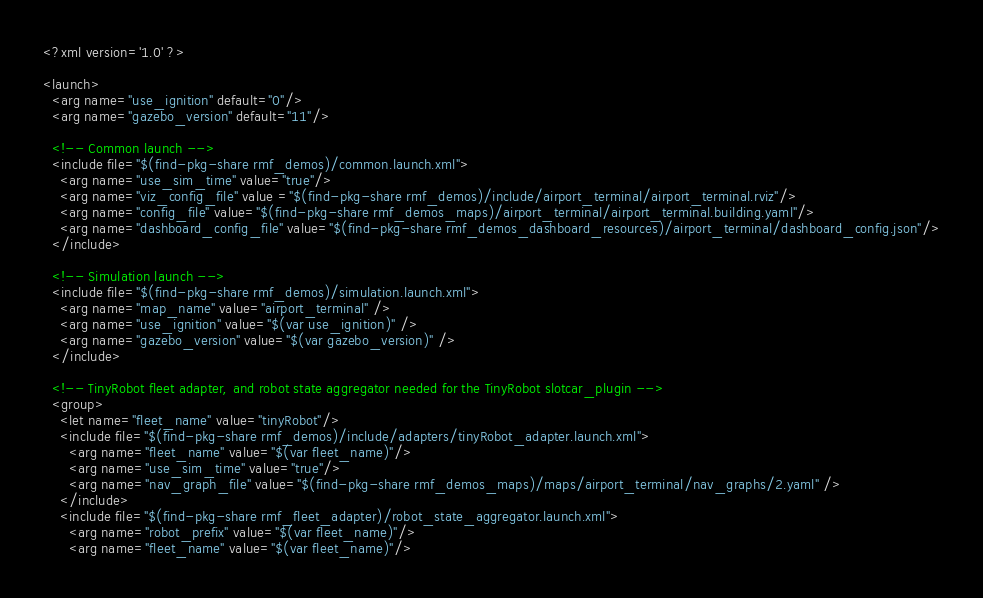<code> <loc_0><loc_0><loc_500><loc_500><_XML_><?xml version='1.0' ?>

<launch>
  <arg name="use_ignition" default="0"/>
  <arg name="gazebo_version" default="11"/>

  <!-- Common launch -->
  <include file="$(find-pkg-share rmf_demos)/common.launch.xml">
    <arg name="use_sim_time" value="true"/>
    <arg name="viz_config_file" value ="$(find-pkg-share rmf_demos)/include/airport_terminal/airport_terminal.rviz"/>
    <arg name="config_file" value="$(find-pkg-share rmf_demos_maps)/airport_terminal/airport_terminal.building.yaml"/>
    <arg name="dashboard_config_file" value="$(find-pkg-share rmf_demos_dashboard_resources)/airport_terminal/dashboard_config.json"/>
  </include>

  <!-- Simulation launch -->
  <include file="$(find-pkg-share rmf_demos)/simulation.launch.xml">
    <arg name="map_name" value="airport_terminal" />
    <arg name="use_ignition" value="$(var use_ignition)" />
    <arg name="gazebo_version" value="$(var gazebo_version)" />
  </include>

  <!-- TinyRobot fleet adapter, and robot state aggregator needed for the TinyRobot slotcar_plugin -->
  <group>
    <let name="fleet_name" value="tinyRobot"/>
    <include file="$(find-pkg-share rmf_demos)/include/adapters/tinyRobot_adapter.launch.xml">
      <arg name="fleet_name" value="$(var fleet_name)"/>
      <arg name="use_sim_time" value="true"/>
      <arg name="nav_graph_file" value="$(find-pkg-share rmf_demos_maps)/maps/airport_terminal/nav_graphs/2.yaml" />
    </include>
    <include file="$(find-pkg-share rmf_fleet_adapter)/robot_state_aggregator.launch.xml">
      <arg name="robot_prefix" value="$(var fleet_name)"/>
      <arg name="fleet_name" value="$(var fleet_name)"/></code> 